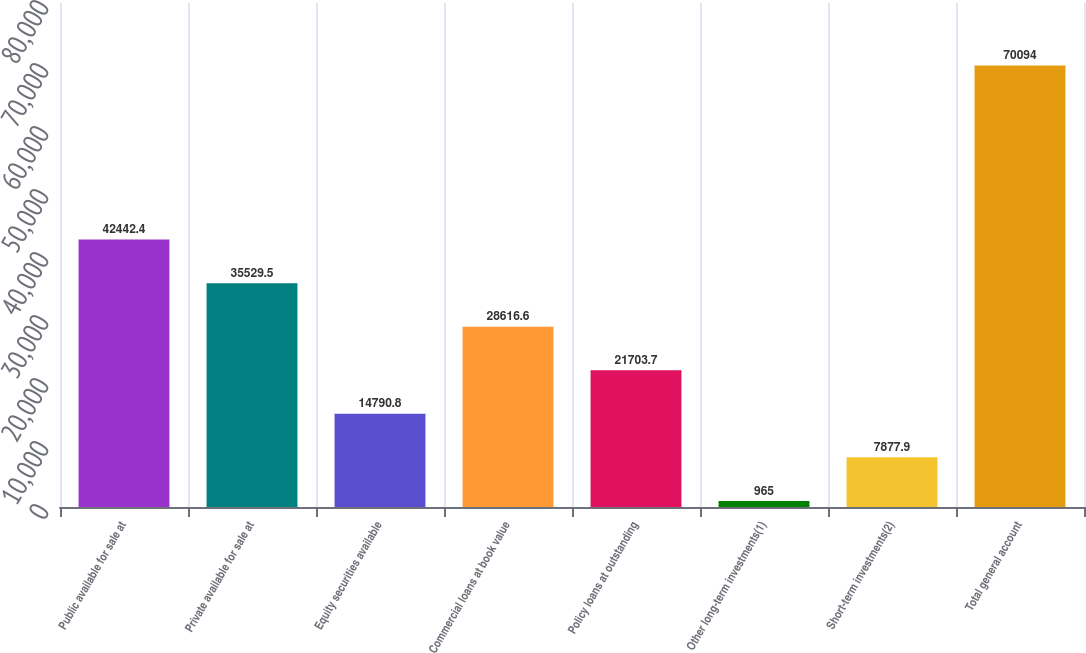Convert chart. <chart><loc_0><loc_0><loc_500><loc_500><bar_chart><fcel>Public available for sale at<fcel>Private available for sale at<fcel>Equity securities available<fcel>Commercial loans at book value<fcel>Policy loans at outstanding<fcel>Other long-term investments(1)<fcel>Short-term investments(2)<fcel>Total general account<nl><fcel>42442.4<fcel>35529.5<fcel>14790.8<fcel>28616.6<fcel>21703.7<fcel>965<fcel>7877.9<fcel>70094<nl></chart> 